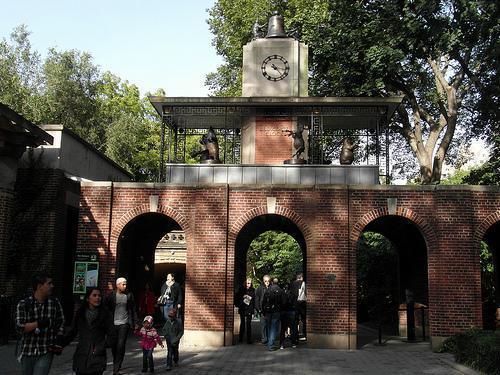How many clocks are in the photo?
Give a very brief answer. 1. 